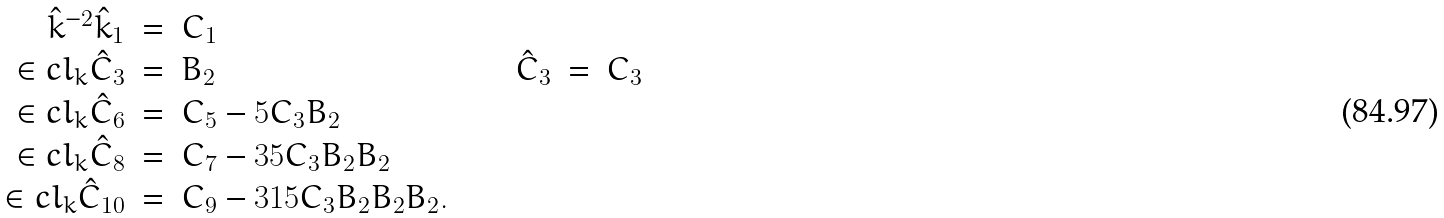<formula> <loc_0><loc_0><loc_500><loc_500>\begin{array} { r c l c r c l } \hat { k } ^ { - 2 } \hat { k } _ { 1 } & = & C _ { 1 } & & & & \\ \in c l _ { k } \hat { C } _ { 3 } & = & B _ { 2 } & \quad & \hat { C } _ { 3 } & = & C _ { 3 } \\ \in c l _ { k } \hat { C } _ { 6 } & = & C _ { 5 } - 5 C _ { 3 } B _ { 2 } & \quad & & & \\ \in c l _ { k } \hat { C } _ { 8 } & = & C _ { 7 } - 3 5 C _ { 3 } B _ { 2 } B _ { 2 } & & & & \\ \in c l _ { k } \hat { C } _ { 1 0 } & = & C _ { 9 } - 3 1 5 C _ { 3 } B _ { 2 } B _ { 2 } B _ { 2 } . & \quad & & & \end{array}</formula> 